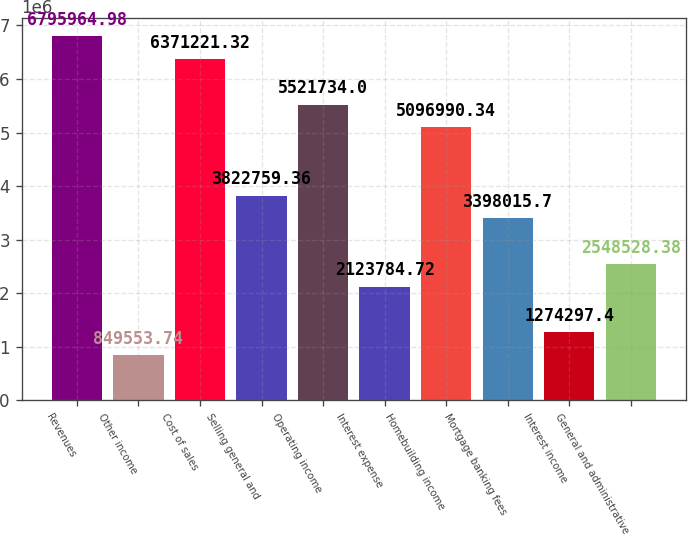Convert chart. <chart><loc_0><loc_0><loc_500><loc_500><bar_chart><fcel>Revenues<fcel>Other income<fcel>Cost of sales<fcel>Selling general and<fcel>Operating income<fcel>Interest expense<fcel>Homebuilding income<fcel>Mortgage banking fees<fcel>Interest income<fcel>General and administrative<nl><fcel>6.79596e+06<fcel>849554<fcel>6.37122e+06<fcel>3.82276e+06<fcel>5.52173e+06<fcel>2.12378e+06<fcel>5.09699e+06<fcel>3.39802e+06<fcel>1.2743e+06<fcel>2.54853e+06<nl></chart> 